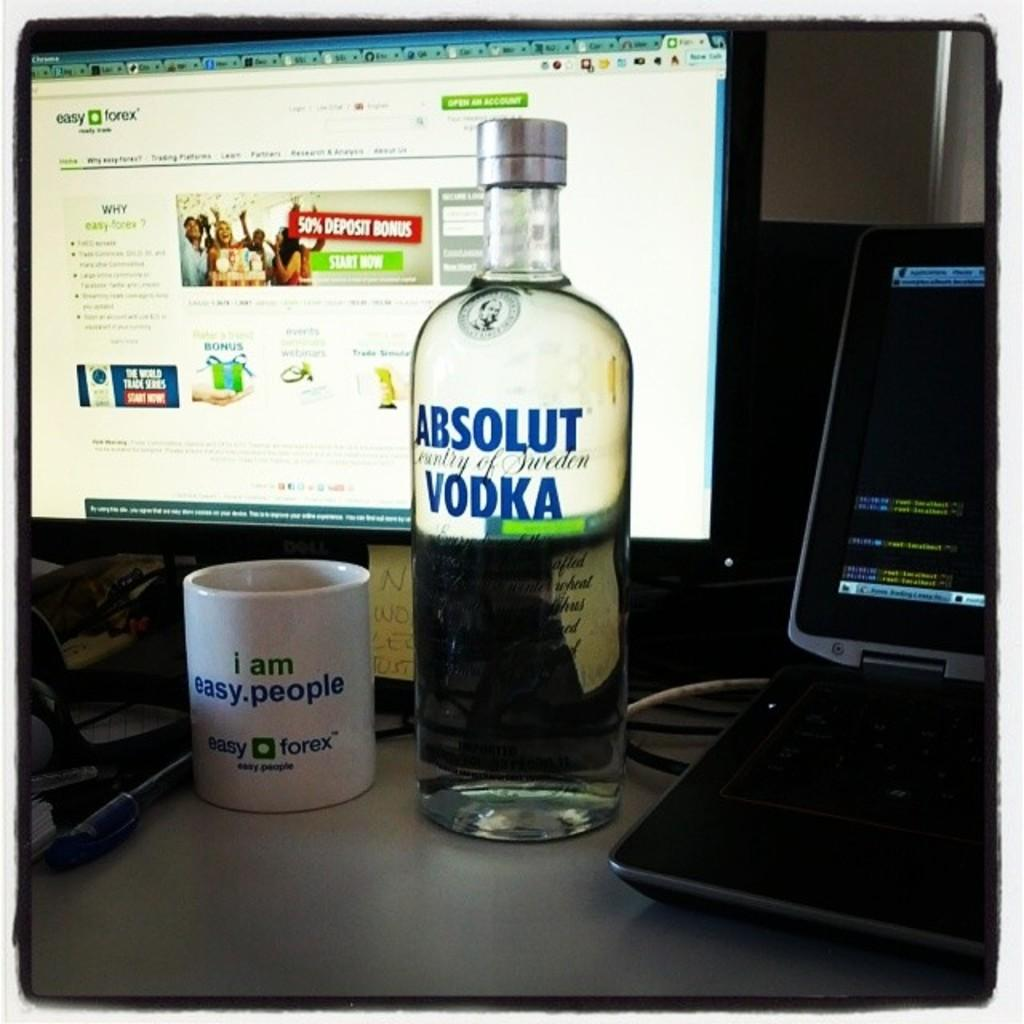Provide a one-sentence caption for the provided image. a vodka bottle that says Absolut Vodka on it. 